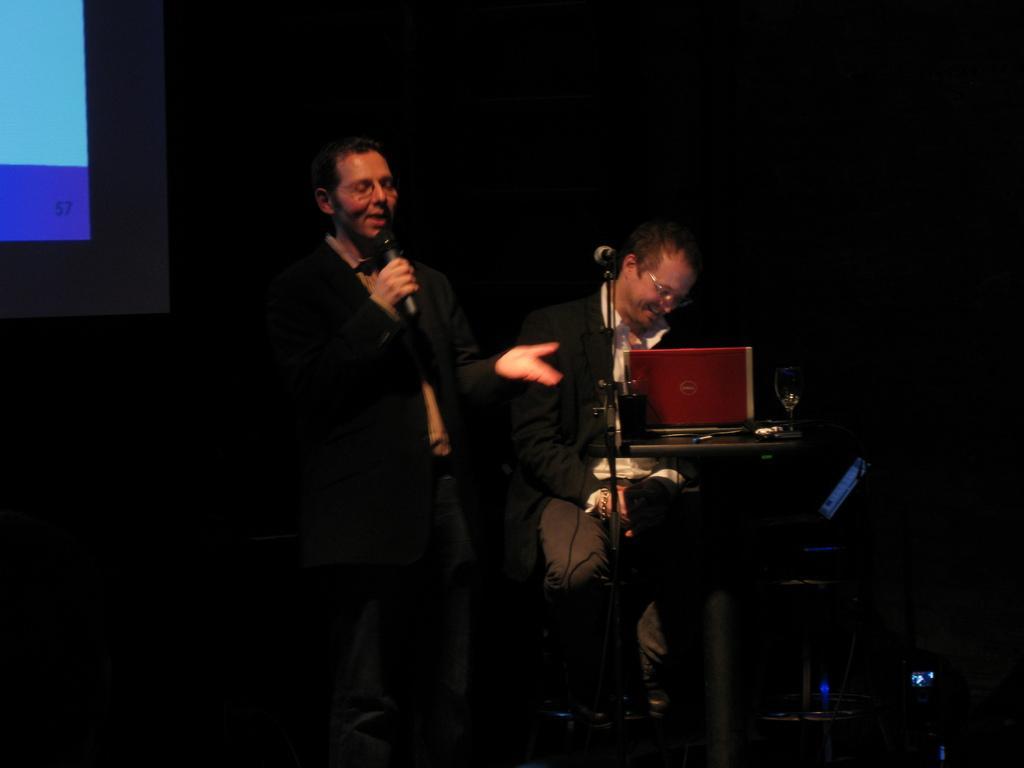Can you describe this image briefly? In the center of the picture there is a man holding a mic, beside him there is another person sitting. In the foreground there is a desk, on the desk there are laptop, paper, glass and other object, beside the table there is a microphone. On the left there is a projector screen. The background is dark. 